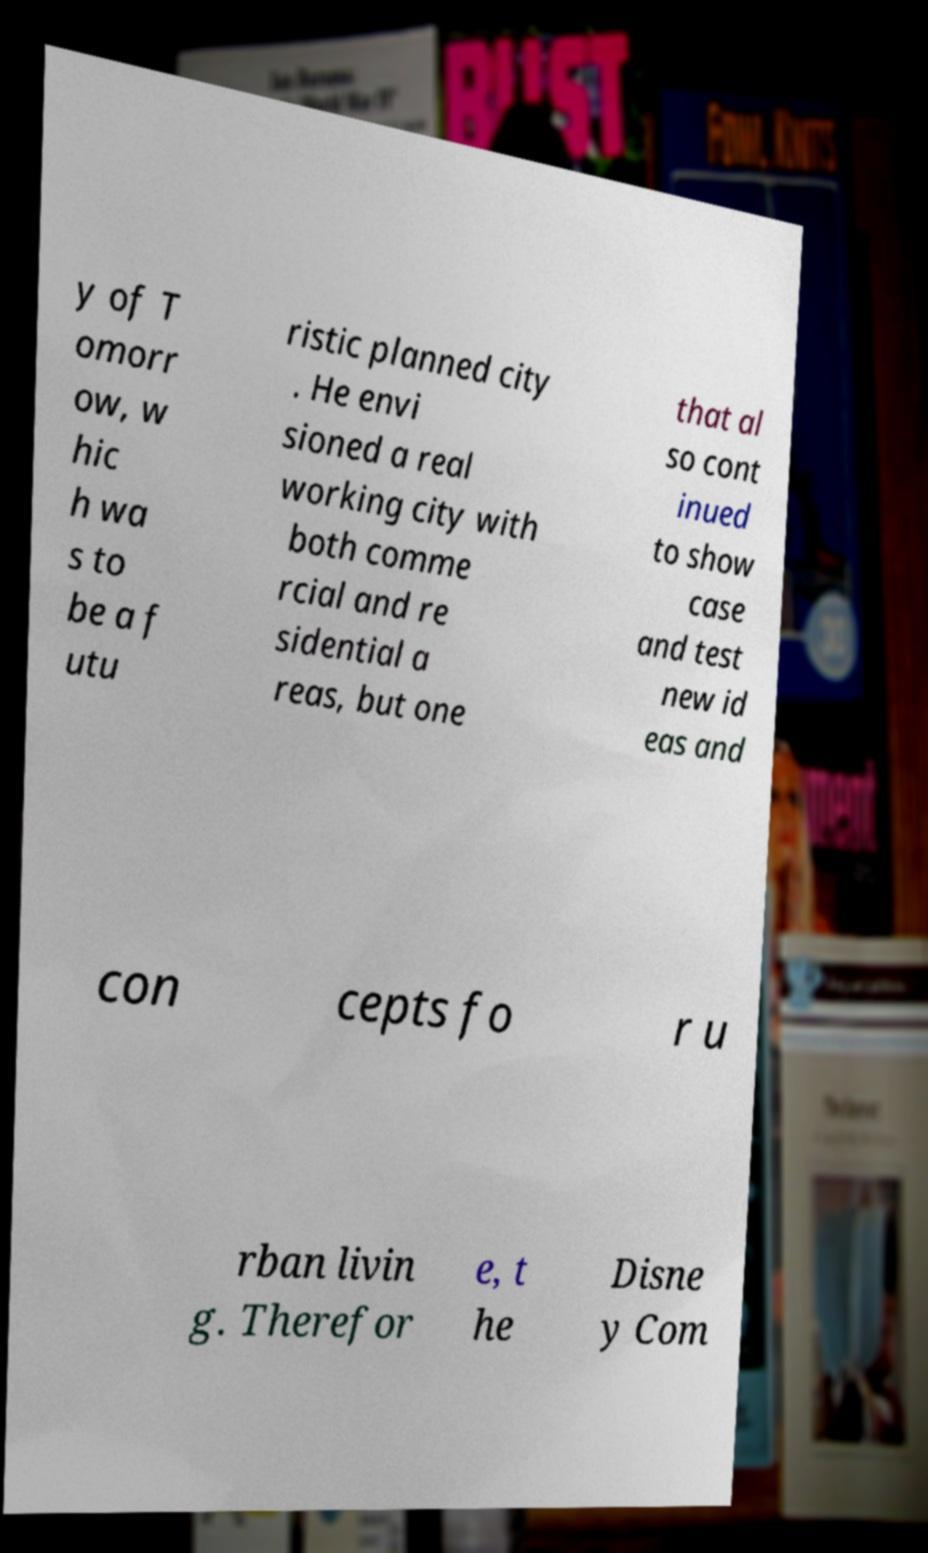What messages or text are displayed in this image? I need them in a readable, typed format. y of T omorr ow, w hic h wa s to be a f utu ristic planned city . He envi sioned a real working city with both comme rcial and re sidential a reas, but one that al so cont inued to show case and test new id eas and con cepts fo r u rban livin g. Therefor e, t he Disne y Com 